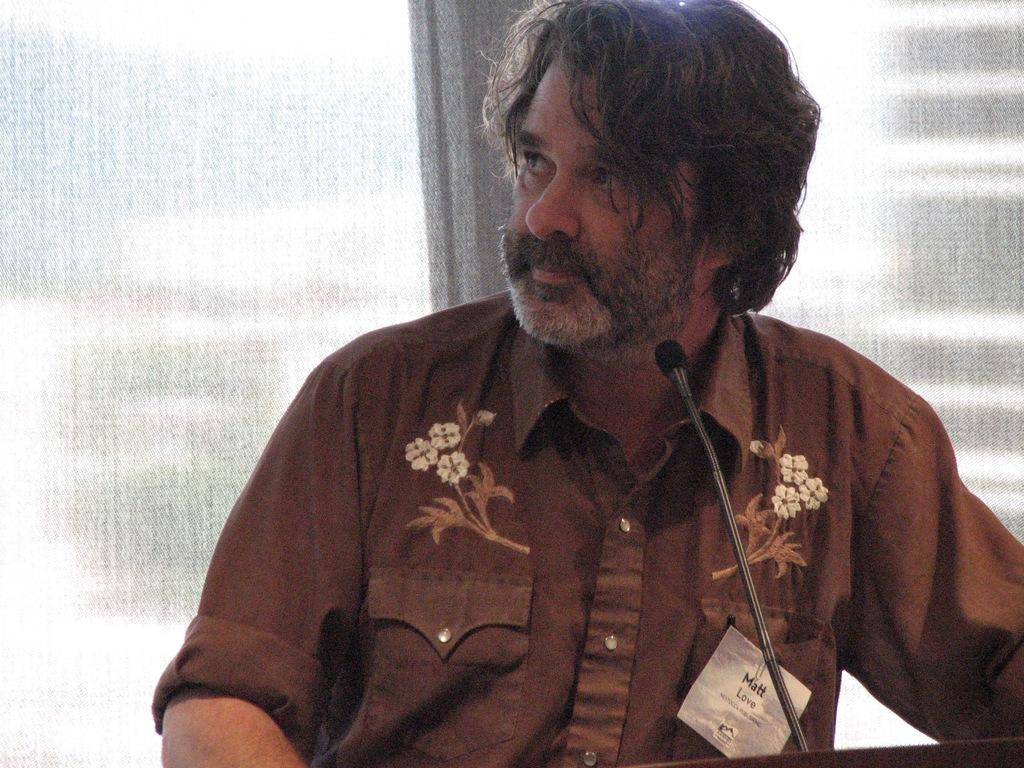Who is present in the image? There is a man in the image. What is the man wearing? The man is wearing a shirt. What object is in front of the man? There is a microphone with a stand in front of the man. What can be seen behind the man? There is an object behind the man. What type of beetle can be seen crawling on the man's vest in the image? There is no beetle or vest present in the image. What type of sticks is the man holding in the image? There is no indication of the man holding any sticks in the image. 